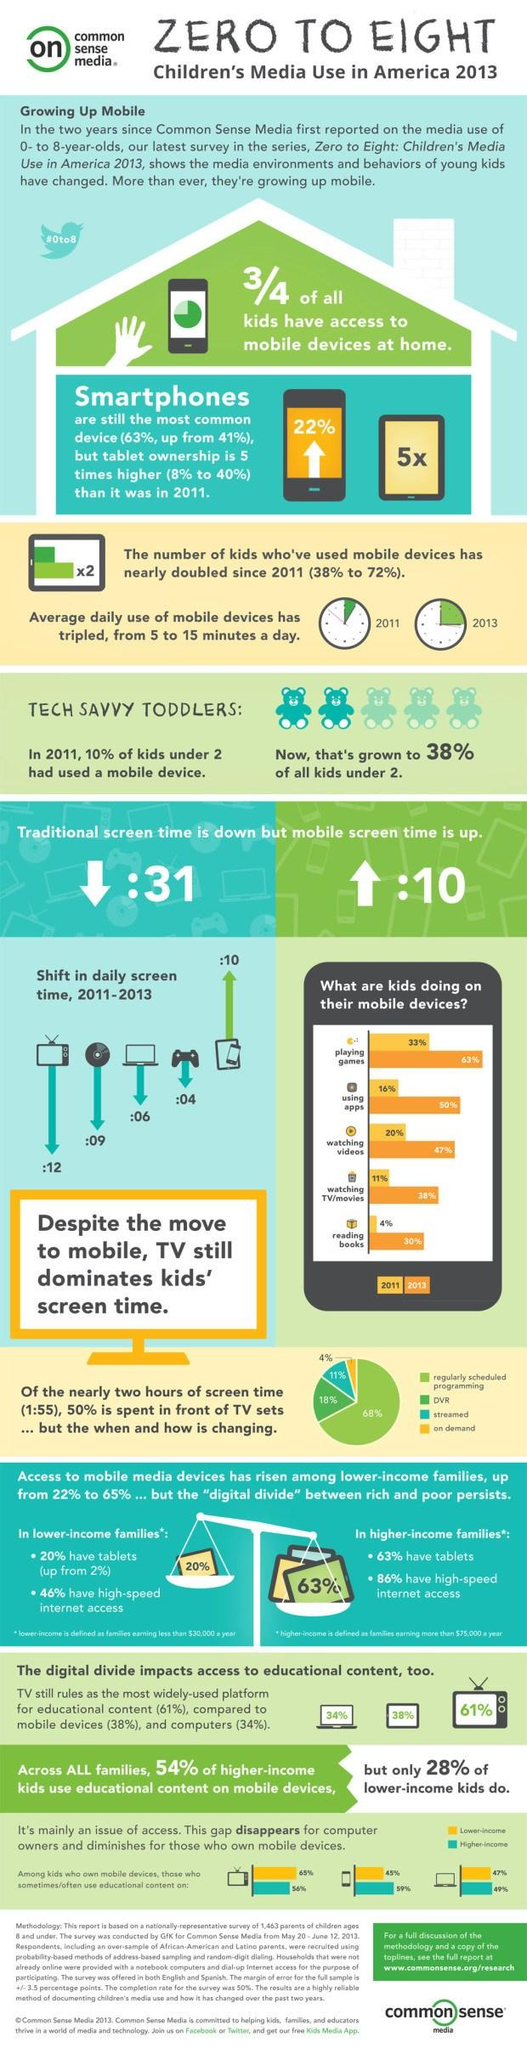Give some essential details in this illustration. Tablet ownership has grown by 32% from 2011. In 2011, 16% of children spent their time using apps. According to recent studies, a quarter of children do not have access to mobile devices at home. According to recent data, only 4% of children watch on-demand programs. The percentage of children watching videos decreased by 27% from 2011 to 2013. 